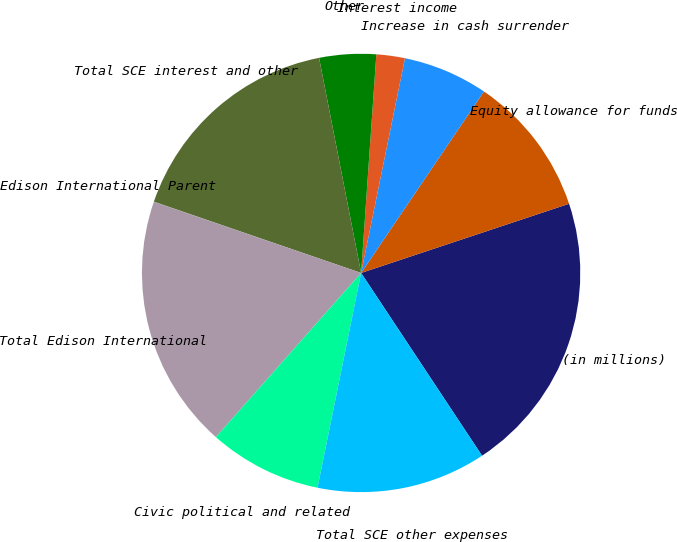<chart> <loc_0><loc_0><loc_500><loc_500><pie_chart><fcel>(in millions)<fcel>Equity allowance for funds<fcel>Increase in cash surrender<fcel>Interest income<fcel>Other<fcel>Total SCE interest and other<fcel>Edison International Parent<fcel>Total Edison International<fcel>Civic political and related<fcel>Total SCE other expenses<nl><fcel>20.81%<fcel>10.42%<fcel>6.26%<fcel>2.1%<fcel>4.18%<fcel>16.65%<fcel>0.02%<fcel>18.73%<fcel>8.34%<fcel>12.49%<nl></chart> 